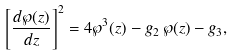<formula> <loc_0><loc_0><loc_500><loc_500>\left [ \frac { d \wp ( z ) } { d z } \right ] ^ { 2 } = 4 \wp ^ { 3 } ( z ) - g _ { 2 } \, \wp ( z ) - g _ { 3 } ,</formula> 